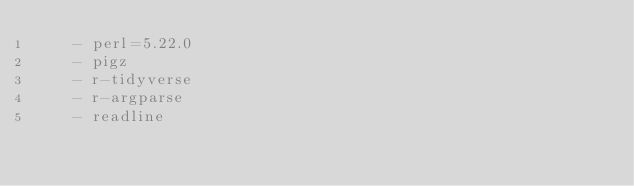Convert code to text. <code><loc_0><loc_0><loc_500><loc_500><_YAML_>    - perl=5.22.0
    - pigz
    - r-tidyverse
    - r-argparse
    - readline
</code> 